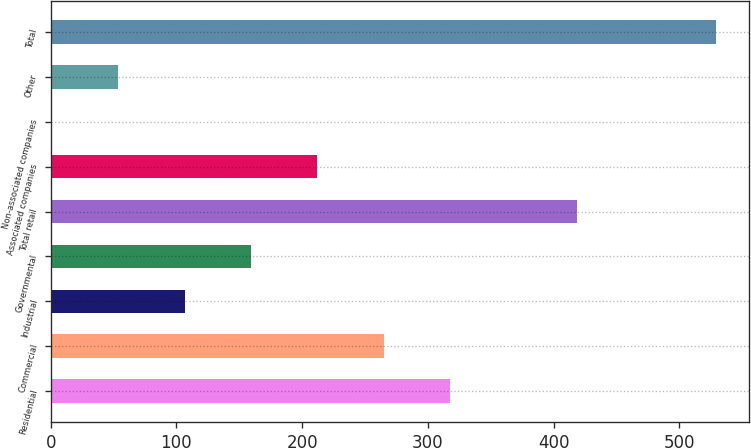Convert chart. <chart><loc_0><loc_0><loc_500><loc_500><bar_chart><fcel>Residential<fcel>Commercial<fcel>Industrial<fcel>Governmental<fcel>Total retail<fcel>Associated companies<fcel>Non-associated companies<fcel>Other<fcel>Total<nl><fcel>317.8<fcel>265<fcel>106.6<fcel>159.4<fcel>419<fcel>212.2<fcel>1<fcel>53.8<fcel>529<nl></chart> 